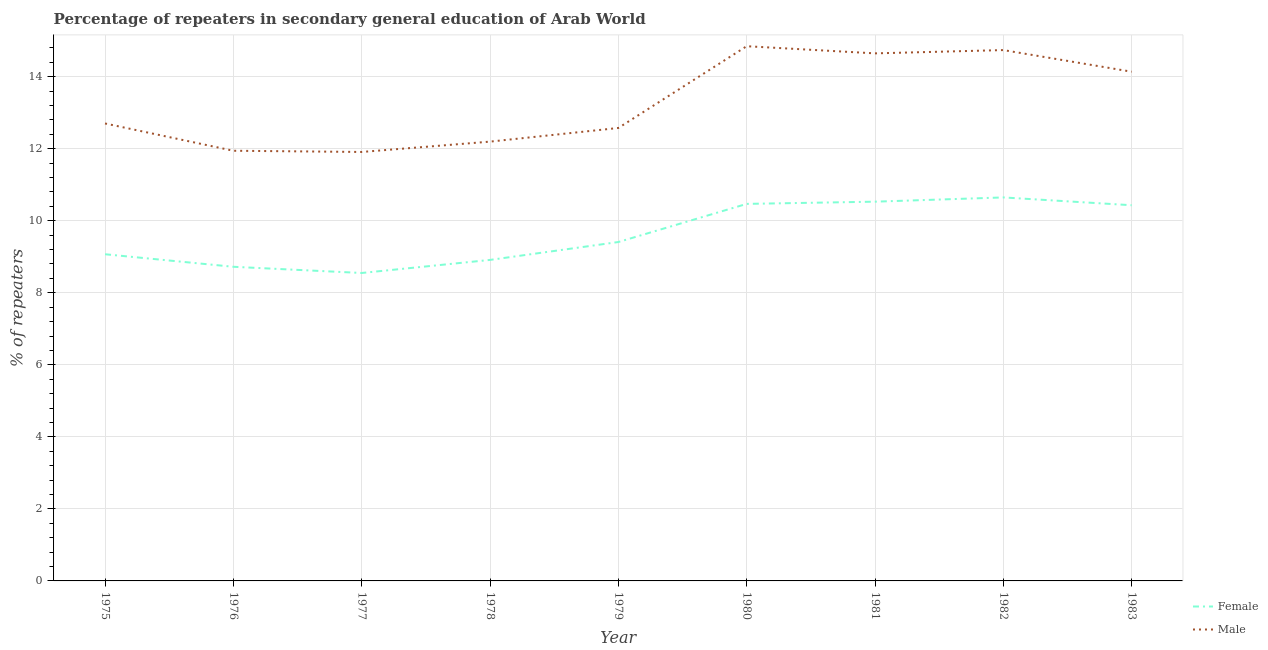Is the number of lines equal to the number of legend labels?
Provide a short and direct response. Yes. What is the percentage of male repeaters in 1975?
Provide a succinct answer. 12.7. Across all years, what is the maximum percentage of male repeaters?
Provide a short and direct response. 14.85. Across all years, what is the minimum percentage of male repeaters?
Your answer should be compact. 11.91. In which year was the percentage of male repeaters minimum?
Your answer should be compact. 1977. What is the total percentage of male repeaters in the graph?
Offer a terse response. 119.7. What is the difference between the percentage of female repeaters in 1978 and that in 1982?
Keep it short and to the point. -1.73. What is the difference between the percentage of male repeaters in 1979 and the percentage of female repeaters in 1982?
Your response must be concise. 1.93. What is the average percentage of male repeaters per year?
Your response must be concise. 13.3. In the year 1976, what is the difference between the percentage of male repeaters and percentage of female repeaters?
Make the answer very short. 3.22. In how many years, is the percentage of female repeaters greater than 11.2 %?
Make the answer very short. 0. What is the ratio of the percentage of male repeaters in 1979 to that in 1980?
Your response must be concise. 0.85. What is the difference between the highest and the second highest percentage of female repeaters?
Give a very brief answer. 0.12. What is the difference between the highest and the lowest percentage of female repeaters?
Make the answer very short. 2.1. In how many years, is the percentage of female repeaters greater than the average percentage of female repeaters taken over all years?
Provide a succinct answer. 4. Is the sum of the percentage of male repeaters in 1978 and 1982 greater than the maximum percentage of female repeaters across all years?
Your response must be concise. Yes. Is the percentage of male repeaters strictly greater than the percentage of female repeaters over the years?
Offer a terse response. Yes. Is the percentage of male repeaters strictly less than the percentage of female repeaters over the years?
Give a very brief answer. No. How many years are there in the graph?
Make the answer very short. 9. What is the difference between two consecutive major ticks on the Y-axis?
Provide a succinct answer. 2. Are the values on the major ticks of Y-axis written in scientific E-notation?
Offer a very short reply. No. Does the graph contain grids?
Your answer should be compact. Yes. What is the title of the graph?
Give a very brief answer. Percentage of repeaters in secondary general education of Arab World. What is the label or title of the X-axis?
Keep it short and to the point. Year. What is the label or title of the Y-axis?
Provide a succinct answer. % of repeaters. What is the % of repeaters of Female in 1975?
Keep it short and to the point. 9.07. What is the % of repeaters of Male in 1975?
Give a very brief answer. 12.7. What is the % of repeaters in Female in 1976?
Keep it short and to the point. 8.72. What is the % of repeaters in Male in 1976?
Provide a succinct answer. 11.94. What is the % of repeaters in Female in 1977?
Keep it short and to the point. 8.55. What is the % of repeaters of Male in 1977?
Give a very brief answer. 11.91. What is the % of repeaters in Female in 1978?
Make the answer very short. 8.91. What is the % of repeaters of Male in 1978?
Provide a succinct answer. 12.2. What is the % of repeaters in Female in 1979?
Provide a succinct answer. 9.41. What is the % of repeaters in Male in 1979?
Provide a short and direct response. 12.58. What is the % of repeaters in Female in 1980?
Give a very brief answer. 10.47. What is the % of repeaters in Male in 1980?
Offer a terse response. 14.85. What is the % of repeaters of Female in 1981?
Offer a terse response. 10.53. What is the % of repeaters of Male in 1981?
Your answer should be very brief. 14.65. What is the % of repeaters in Female in 1982?
Provide a succinct answer. 10.65. What is the % of repeaters in Male in 1982?
Your answer should be very brief. 14.74. What is the % of repeaters in Female in 1983?
Provide a succinct answer. 10.43. What is the % of repeaters of Male in 1983?
Provide a short and direct response. 14.14. Across all years, what is the maximum % of repeaters in Female?
Provide a succinct answer. 10.65. Across all years, what is the maximum % of repeaters of Male?
Provide a succinct answer. 14.85. Across all years, what is the minimum % of repeaters in Female?
Provide a succinct answer. 8.55. Across all years, what is the minimum % of repeaters in Male?
Give a very brief answer. 11.91. What is the total % of repeaters of Female in the graph?
Keep it short and to the point. 86.74. What is the total % of repeaters in Male in the graph?
Ensure brevity in your answer.  119.7. What is the difference between the % of repeaters of Female in 1975 and that in 1976?
Offer a very short reply. 0.35. What is the difference between the % of repeaters in Male in 1975 and that in 1976?
Your answer should be very brief. 0.76. What is the difference between the % of repeaters in Female in 1975 and that in 1977?
Your answer should be very brief. 0.52. What is the difference between the % of repeaters of Male in 1975 and that in 1977?
Provide a succinct answer. 0.79. What is the difference between the % of repeaters of Female in 1975 and that in 1978?
Provide a short and direct response. 0.16. What is the difference between the % of repeaters of Male in 1975 and that in 1978?
Offer a very short reply. 0.5. What is the difference between the % of repeaters in Female in 1975 and that in 1979?
Your response must be concise. -0.34. What is the difference between the % of repeaters in Male in 1975 and that in 1979?
Give a very brief answer. 0.12. What is the difference between the % of repeaters of Female in 1975 and that in 1980?
Ensure brevity in your answer.  -1.4. What is the difference between the % of repeaters of Male in 1975 and that in 1980?
Provide a succinct answer. -2.15. What is the difference between the % of repeaters in Female in 1975 and that in 1981?
Give a very brief answer. -1.46. What is the difference between the % of repeaters in Male in 1975 and that in 1981?
Your answer should be compact. -1.95. What is the difference between the % of repeaters in Female in 1975 and that in 1982?
Provide a short and direct response. -1.58. What is the difference between the % of repeaters of Male in 1975 and that in 1982?
Give a very brief answer. -2.04. What is the difference between the % of repeaters of Female in 1975 and that in 1983?
Your answer should be compact. -1.36. What is the difference between the % of repeaters in Male in 1975 and that in 1983?
Provide a short and direct response. -1.44. What is the difference between the % of repeaters of Female in 1976 and that in 1977?
Give a very brief answer. 0.17. What is the difference between the % of repeaters in Male in 1976 and that in 1977?
Make the answer very short. 0.03. What is the difference between the % of repeaters in Female in 1976 and that in 1978?
Your answer should be very brief. -0.19. What is the difference between the % of repeaters of Male in 1976 and that in 1978?
Your answer should be compact. -0.25. What is the difference between the % of repeaters of Female in 1976 and that in 1979?
Offer a terse response. -0.69. What is the difference between the % of repeaters of Male in 1976 and that in 1979?
Provide a short and direct response. -0.63. What is the difference between the % of repeaters in Female in 1976 and that in 1980?
Give a very brief answer. -1.75. What is the difference between the % of repeaters in Male in 1976 and that in 1980?
Your response must be concise. -2.9. What is the difference between the % of repeaters of Female in 1976 and that in 1981?
Your answer should be very brief. -1.81. What is the difference between the % of repeaters of Male in 1976 and that in 1981?
Make the answer very short. -2.7. What is the difference between the % of repeaters of Female in 1976 and that in 1982?
Offer a terse response. -1.93. What is the difference between the % of repeaters of Male in 1976 and that in 1982?
Make the answer very short. -2.8. What is the difference between the % of repeaters in Female in 1976 and that in 1983?
Provide a short and direct response. -1.71. What is the difference between the % of repeaters of Male in 1976 and that in 1983?
Provide a succinct answer. -2.19. What is the difference between the % of repeaters of Female in 1977 and that in 1978?
Provide a short and direct response. -0.36. What is the difference between the % of repeaters in Male in 1977 and that in 1978?
Keep it short and to the point. -0.29. What is the difference between the % of repeaters in Female in 1977 and that in 1979?
Offer a very short reply. -0.86. What is the difference between the % of repeaters in Male in 1977 and that in 1979?
Your response must be concise. -0.67. What is the difference between the % of repeaters in Female in 1977 and that in 1980?
Provide a short and direct response. -1.92. What is the difference between the % of repeaters in Male in 1977 and that in 1980?
Your answer should be compact. -2.94. What is the difference between the % of repeaters in Female in 1977 and that in 1981?
Provide a short and direct response. -1.98. What is the difference between the % of repeaters in Male in 1977 and that in 1981?
Offer a very short reply. -2.74. What is the difference between the % of repeaters of Female in 1977 and that in 1982?
Give a very brief answer. -2.1. What is the difference between the % of repeaters of Male in 1977 and that in 1982?
Offer a terse response. -2.83. What is the difference between the % of repeaters of Female in 1977 and that in 1983?
Keep it short and to the point. -1.88. What is the difference between the % of repeaters of Male in 1977 and that in 1983?
Provide a short and direct response. -2.23. What is the difference between the % of repeaters in Female in 1978 and that in 1979?
Your response must be concise. -0.5. What is the difference between the % of repeaters of Male in 1978 and that in 1979?
Make the answer very short. -0.38. What is the difference between the % of repeaters in Female in 1978 and that in 1980?
Make the answer very short. -1.56. What is the difference between the % of repeaters in Male in 1978 and that in 1980?
Your answer should be very brief. -2.65. What is the difference between the % of repeaters in Female in 1978 and that in 1981?
Your answer should be very brief. -1.62. What is the difference between the % of repeaters of Male in 1978 and that in 1981?
Ensure brevity in your answer.  -2.45. What is the difference between the % of repeaters in Female in 1978 and that in 1982?
Your answer should be compact. -1.74. What is the difference between the % of repeaters of Male in 1978 and that in 1982?
Your response must be concise. -2.54. What is the difference between the % of repeaters in Female in 1978 and that in 1983?
Your answer should be compact. -1.52. What is the difference between the % of repeaters of Male in 1978 and that in 1983?
Provide a short and direct response. -1.94. What is the difference between the % of repeaters in Female in 1979 and that in 1980?
Provide a succinct answer. -1.06. What is the difference between the % of repeaters of Male in 1979 and that in 1980?
Offer a terse response. -2.27. What is the difference between the % of repeaters of Female in 1979 and that in 1981?
Keep it short and to the point. -1.12. What is the difference between the % of repeaters in Male in 1979 and that in 1981?
Provide a succinct answer. -2.07. What is the difference between the % of repeaters in Female in 1979 and that in 1982?
Offer a very short reply. -1.24. What is the difference between the % of repeaters in Male in 1979 and that in 1982?
Offer a terse response. -2.16. What is the difference between the % of repeaters in Female in 1979 and that in 1983?
Provide a succinct answer. -1.02. What is the difference between the % of repeaters of Male in 1979 and that in 1983?
Ensure brevity in your answer.  -1.56. What is the difference between the % of repeaters of Female in 1980 and that in 1981?
Your response must be concise. -0.06. What is the difference between the % of repeaters in Male in 1980 and that in 1981?
Your answer should be very brief. 0.2. What is the difference between the % of repeaters in Female in 1980 and that in 1982?
Offer a very short reply. -0.18. What is the difference between the % of repeaters of Male in 1980 and that in 1982?
Your response must be concise. 0.11. What is the difference between the % of repeaters of Female in 1980 and that in 1983?
Provide a succinct answer. 0.04. What is the difference between the % of repeaters in Male in 1980 and that in 1983?
Provide a succinct answer. 0.71. What is the difference between the % of repeaters of Female in 1981 and that in 1982?
Keep it short and to the point. -0.12. What is the difference between the % of repeaters of Male in 1981 and that in 1982?
Make the answer very short. -0.09. What is the difference between the % of repeaters of Female in 1981 and that in 1983?
Your answer should be very brief. 0.1. What is the difference between the % of repeaters of Male in 1981 and that in 1983?
Your answer should be very brief. 0.51. What is the difference between the % of repeaters in Female in 1982 and that in 1983?
Your answer should be very brief. 0.22. What is the difference between the % of repeaters of Male in 1982 and that in 1983?
Ensure brevity in your answer.  0.6. What is the difference between the % of repeaters of Female in 1975 and the % of repeaters of Male in 1976?
Offer a terse response. -2.87. What is the difference between the % of repeaters of Female in 1975 and the % of repeaters of Male in 1977?
Offer a terse response. -2.84. What is the difference between the % of repeaters in Female in 1975 and the % of repeaters in Male in 1978?
Your answer should be very brief. -3.13. What is the difference between the % of repeaters of Female in 1975 and the % of repeaters of Male in 1979?
Give a very brief answer. -3.51. What is the difference between the % of repeaters in Female in 1975 and the % of repeaters in Male in 1980?
Make the answer very short. -5.78. What is the difference between the % of repeaters in Female in 1975 and the % of repeaters in Male in 1981?
Ensure brevity in your answer.  -5.58. What is the difference between the % of repeaters of Female in 1975 and the % of repeaters of Male in 1982?
Your answer should be very brief. -5.67. What is the difference between the % of repeaters of Female in 1975 and the % of repeaters of Male in 1983?
Ensure brevity in your answer.  -5.07. What is the difference between the % of repeaters of Female in 1976 and the % of repeaters of Male in 1977?
Ensure brevity in your answer.  -3.19. What is the difference between the % of repeaters of Female in 1976 and the % of repeaters of Male in 1978?
Give a very brief answer. -3.48. What is the difference between the % of repeaters of Female in 1976 and the % of repeaters of Male in 1979?
Your answer should be compact. -3.85. What is the difference between the % of repeaters of Female in 1976 and the % of repeaters of Male in 1980?
Offer a terse response. -6.12. What is the difference between the % of repeaters in Female in 1976 and the % of repeaters in Male in 1981?
Give a very brief answer. -5.93. What is the difference between the % of repeaters of Female in 1976 and the % of repeaters of Male in 1982?
Offer a very short reply. -6.02. What is the difference between the % of repeaters of Female in 1976 and the % of repeaters of Male in 1983?
Make the answer very short. -5.42. What is the difference between the % of repeaters in Female in 1977 and the % of repeaters in Male in 1978?
Your response must be concise. -3.65. What is the difference between the % of repeaters of Female in 1977 and the % of repeaters of Male in 1979?
Offer a terse response. -4.03. What is the difference between the % of repeaters of Female in 1977 and the % of repeaters of Male in 1980?
Your answer should be very brief. -6.3. What is the difference between the % of repeaters of Female in 1977 and the % of repeaters of Male in 1981?
Your answer should be compact. -6.1. What is the difference between the % of repeaters in Female in 1977 and the % of repeaters in Male in 1982?
Provide a succinct answer. -6.19. What is the difference between the % of repeaters of Female in 1977 and the % of repeaters of Male in 1983?
Provide a short and direct response. -5.59. What is the difference between the % of repeaters in Female in 1978 and the % of repeaters in Male in 1979?
Provide a short and direct response. -3.66. What is the difference between the % of repeaters in Female in 1978 and the % of repeaters in Male in 1980?
Your response must be concise. -5.93. What is the difference between the % of repeaters in Female in 1978 and the % of repeaters in Male in 1981?
Offer a terse response. -5.73. What is the difference between the % of repeaters in Female in 1978 and the % of repeaters in Male in 1982?
Make the answer very short. -5.83. What is the difference between the % of repeaters of Female in 1978 and the % of repeaters of Male in 1983?
Make the answer very short. -5.23. What is the difference between the % of repeaters in Female in 1979 and the % of repeaters in Male in 1980?
Your answer should be very brief. -5.44. What is the difference between the % of repeaters of Female in 1979 and the % of repeaters of Male in 1981?
Your answer should be compact. -5.24. What is the difference between the % of repeaters in Female in 1979 and the % of repeaters in Male in 1982?
Your answer should be compact. -5.33. What is the difference between the % of repeaters of Female in 1979 and the % of repeaters of Male in 1983?
Provide a short and direct response. -4.73. What is the difference between the % of repeaters of Female in 1980 and the % of repeaters of Male in 1981?
Ensure brevity in your answer.  -4.18. What is the difference between the % of repeaters of Female in 1980 and the % of repeaters of Male in 1982?
Offer a terse response. -4.27. What is the difference between the % of repeaters of Female in 1980 and the % of repeaters of Male in 1983?
Provide a short and direct response. -3.67. What is the difference between the % of repeaters of Female in 1981 and the % of repeaters of Male in 1982?
Give a very brief answer. -4.21. What is the difference between the % of repeaters of Female in 1981 and the % of repeaters of Male in 1983?
Your answer should be compact. -3.61. What is the difference between the % of repeaters of Female in 1982 and the % of repeaters of Male in 1983?
Your answer should be very brief. -3.49. What is the average % of repeaters in Female per year?
Your response must be concise. 9.64. What is the average % of repeaters in Male per year?
Your answer should be very brief. 13.3. In the year 1975, what is the difference between the % of repeaters in Female and % of repeaters in Male?
Your response must be concise. -3.63. In the year 1976, what is the difference between the % of repeaters in Female and % of repeaters in Male?
Offer a very short reply. -3.22. In the year 1977, what is the difference between the % of repeaters in Female and % of repeaters in Male?
Provide a short and direct response. -3.36. In the year 1978, what is the difference between the % of repeaters of Female and % of repeaters of Male?
Make the answer very short. -3.28. In the year 1979, what is the difference between the % of repeaters in Female and % of repeaters in Male?
Your answer should be compact. -3.17. In the year 1980, what is the difference between the % of repeaters of Female and % of repeaters of Male?
Offer a very short reply. -4.38. In the year 1981, what is the difference between the % of repeaters of Female and % of repeaters of Male?
Make the answer very short. -4.12. In the year 1982, what is the difference between the % of repeaters of Female and % of repeaters of Male?
Your answer should be compact. -4.09. In the year 1983, what is the difference between the % of repeaters of Female and % of repeaters of Male?
Make the answer very short. -3.71. What is the ratio of the % of repeaters of Female in 1975 to that in 1976?
Offer a very short reply. 1.04. What is the ratio of the % of repeaters of Male in 1975 to that in 1976?
Ensure brevity in your answer.  1.06. What is the ratio of the % of repeaters in Female in 1975 to that in 1977?
Offer a very short reply. 1.06. What is the ratio of the % of repeaters in Male in 1975 to that in 1977?
Provide a succinct answer. 1.07. What is the ratio of the % of repeaters in Female in 1975 to that in 1978?
Keep it short and to the point. 1.02. What is the ratio of the % of repeaters in Male in 1975 to that in 1978?
Offer a very short reply. 1.04. What is the ratio of the % of repeaters of Female in 1975 to that in 1979?
Offer a terse response. 0.96. What is the ratio of the % of repeaters of Male in 1975 to that in 1979?
Offer a very short reply. 1.01. What is the ratio of the % of repeaters in Female in 1975 to that in 1980?
Provide a short and direct response. 0.87. What is the ratio of the % of repeaters in Male in 1975 to that in 1980?
Your response must be concise. 0.86. What is the ratio of the % of repeaters in Female in 1975 to that in 1981?
Give a very brief answer. 0.86. What is the ratio of the % of repeaters of Male in 1975 to that in 1981?
Your answer should be very brief. 0.87. What is the ratio of the % of repeaters of Female in 1975 to that in 1982?
Your answer should be compact. 0.85. What is the ratio of the % of repeaters in Male in 1975 to that in 1982?
Offer a terse response. 0.86. What is the ratio of the % of repeaters in Female in 1975 to that in 1983?
Offer a terse response. 0.87. What is the ratio of the % of repeaters in Male in 1975 to that in 1983?
Make the answer very short. 0.9. What is the ratio of the % of repeaters of Female in 1976 to that in 1977?
Give a very brief answer. 1.02. What is the ratio of the % of repeaters of Female in 1976 to that in 1978?
Your answer should be compact. 0.98. What is the ratio of the % of repeaters of Male in 1976 to that in 1978?
Provide a short and direct response. 0.98. What is the ratio of the % of repeaters in Female in 1976 to that in 1979?
Provide a succinct answer. 0.93. What is the ratio of the % of repeaters in Male in 1976 to that in 1979?
Keep it short and to the point. 0.95. What is the ratio of the % of repeaters in Female in 1976 to that in 1980?
Offer a terse response. 0.83. What is the ratio of the % of repeaters in Male in 1976 to that in 1980?
Make the answer very short. 0.8. What is the ratio of the % of repeaters in Female in 1976 to that in 1981?
Your response must be concise. 0.83. What is the ratio of the % of repeaters of Male in 1976 to that in 1981?
Provide a short and direct response. 0.82. What is the ratio of the % of repeaters of Female in 1976 to that in 1982?
Make the answer very short. 0.82. What is the ratio of the % of repeaters of Male in 1976 to that in 1982?
Provide a succinct answer. 0.81. What is the ratio of the % of repeaters in Female in 1976 to that in 1983?
Offer a very short reply. 0.84. What is the ratio of the % of repeaters of Male in 1976 to that in 1983?
Provide a short and direct response. 0.84. What is the ratio of the % of repeaters of Female in 1977 to that in 1978?
Your response must be concise. 0.96. What is the ratio of the % of repeaters in Male in 1977 to that in 1978?
Give a very brief answer. 0.98. What is the ratio of the % of repeaters in Female in 1977 to that in 1979?
Provide a short and direct response. 0.91. What is the ratio of the % of repeaters of Male in 1977 to that in 1979?
Your response must be concise. 0.95. What is the ratio of the % of repeaters of Female in 1977 to that in 1980?
Ensure brevity in your answer.  0.82. What is the ratio of the % of repeaters in Male in 1977 to that in 1980?
Give a very brief answer. 0.8. What is the ratio of the % of repeaters in Female in 1977 to that in 1981?
Your answer should be very brief. 0.81. What is the ratio of the % of repeaters in Male in 1977 to that in 1981?
Offer a terse response. 0.81. What is the ratio of the % of repeaters of Female in 1977 to that in 1982?
Keep it short and to the point. 0.8. What is the ratio of the % of repeaters of Male in 1977 to that in 1982?
Make the answer very short. 0.81. What is the ratio of the % of repeaters in Female in 1977 to that in 1983?
Provide a short and direct response. 0.82. What is the ratio of the % of repeaters in Male in 1977 to that in 1983?
Ensure brevity in your answer.  0.84. What is the ratio of the % of repeaters in Female in 1978 to that in 1979?
Give a very brief answer. 0.95. What is the ratio of the % of repeaters of Male in 1978 to that in 1979?
Make the answer very short. 0.97. What is the ratio of the % of repeaters of Female in 1978 to that in 1980?
Keep it short and to the point. 0.85. What is the ratio of the % of repeaters in Male in 1978 to that in 1980?
Make the answer very short. 0.82. What is the ratio of the % of repeaters in Female in 1978 to that in 1981?
Offer a very short reply. 0.85. What is the ratio of the % of repeaters of Male in 1978 to that in 1981?
Offer a very short reply. 0.83. What is the ratio of the % of repeaters in Female in 1978 to that in 1982?
Your answer should be very brief. 0.84. What is the ratio of the % of repeaters in Male in 1978 to that in 1982?
Offer a terse response. 0.83. What is the ratio of the % of repeaters in Female in 1978 to that in 1983?
Offer a very short reply. 0.85. What is the ratio of the % of repeaters in Male in 1978 to that in 1983?
Keep it short and to the point. 0.86. What is the ratio of the % of repeaters of Female in 1979 to that in 1980?
Provide a succinct answer. 0.9. What is the ratio of the % of repeaters of Male in 1979 to that in 1980?
Give a very brief answer. 0.85. What is the ratio of the % of repeaters of Female in 1979 to that in 1981?
Offer a very short reply. 0.89. What is the ratio of the % of repeaters in Male in 1979 to that in 1981?
Make the answer very short. 0.86. What is the ratio of the % of repeaters in Female in 1979 to that in 1982?
Your answer should be very brief. 0.88. What is the ratio of the % of repeaters in Male in 1979 to that in 1982?
Keep it short and to the point. 0.85. What is the ratio of the % of repeaters in Female in 1979 to that in 1983?
Offer a very short reply. 0.9. What is the ratio of the % of repeaters in Male in 1979 to that in 1983?
Your answer should be very brief. 0.89. What is the ratio of the % of repeaters in Male in 1980 to that in 1981?
Make the answer very short. 1.01. What is the ratio of the % of repeaters in Female in 1980 to that in 1982?
Keep it short and to the point. 0.98. What is the ratio of the % of repeaters of Male in 1980 to that in 1982?
Your answer should be compact. 1.01. What is the ratio of the % of repeaters in Female in 1980 to that in 1983?
Provide a succinct answer. 1. What is the ratio of the % of repeaters of Male in 1980 to that in 1983?
Your answer should be compact. 1.05. What is the ratio of the % of repeaters in Female in 1981 to that in 1982?
Ensure brevity in your answer.  0.99. What is the ratio of the % of repeaters in Male in 1981 to that in 1982?
Provide a short and direct response. 0.99. What is the ratio of the % of repeaters of Female in 1981 to that in 1983?
Ensure brevity in your answer.  1.01. What is the ratio of the % of repeaters of Male in 1981 to that in 1983?
Ensure brevity in your answer.  1.04. What is the ratio of the % of repeaters in Female in 1982 to that in 1983?
Your answer should be very brief. 1.02. What is the ratio of the % of repeaters in Male in 1982 to that in 1983?
Ensure brevity in your answer.  1.04. What is the difference between the highest and the second highest % of repeaters of Female?
Make the answer very short. 0.12. What is the difference between the highest and the second highest % of repeaters of Male?
Keep it short and to the point. 0.11. What is the difference between the highest and the lowest % of repeaters in Female?
Provide a short and direct response. 2.1. What is the difference between the highest and the lowest % of repeaters in Male?
Ensure brevity in your answer.  2.94. 